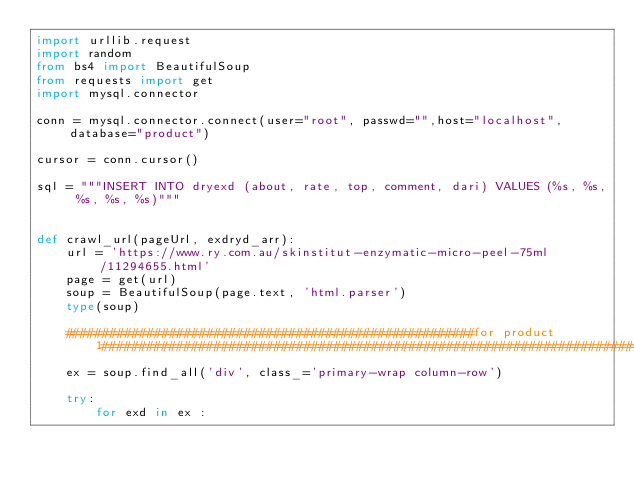<code> <loc_0><loc_0><loc_500><loc_500><_Python_>import urllib.request
import random
from bs4 import BeautifulSoup
from requests import get
import mysql.connector

conn = mysql.connector.connect(user="root", passwd="",host="localhost", database="product")

cursor = conn.cursor()

sql = """INSERT INTO dryexd (about, rate, top, comment, dari) VALUES (%s, %s, %s, %s, %s)"""


def crawl_url(pageUrl, exdryd_arr):
    url = 'https://www.ry.com.au/skinstitut-enzymatic-micro-peel-75ml/11294655.html'
    page = get(url)
    soup = BeautifulSoup(page.text, 'html.parser')
    type(soup)

    #######################################################for product 1############################################################################
    ex = soup.find_all('div', class_='primary-wrap column-row')

    try:
        for exd in ex :
</code> 